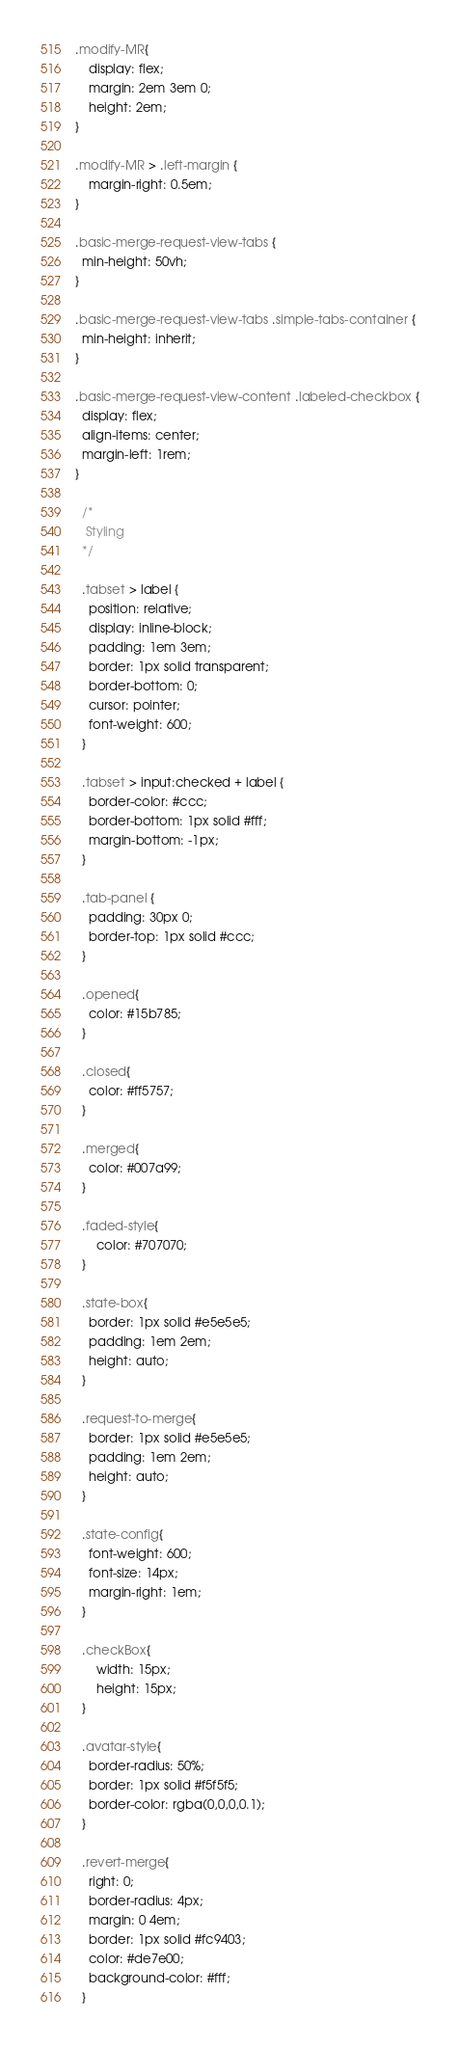Convert code to text. <code><loc_0><loc_0><loc_500><loc_500><_CSS_>.modify-MR{
    display: flex;
    margin: 2em 3em 0;
    height: 2em;
}

.modify-MR > .left-margin {
    margin-right: 0.5em;
}

.basic-merge-request-view-tabs {
  min-height: 50vh;
}

.basic-merge-request-view-tabs .simple-tabs-container {
  min-height: inherit;
}

.basic-merge-request-view-content .labeled-checkbox {
  display: flex;
  align-items: center;
  margin-left: 1rem;
}

  /*
   Styling
  */

  .tabset > label {
    position: relative;
    display: inline-block;
    padding: 1em 3em;
    border: 1px solid transparent;
    border-bottom: 0;
    cursor: pointer;
    font-weight: 600;
  }

  .tabset > input:checked + label {
    border-color: #ccc;
    border-bottom: 1px solid #fff;
    margin-bottom: -1px;
  }

  .tab-panel {
    padding: 30px 0;
    border-top: 1px solid #ccc;
  }

  .opened{
    color: #15b785;
  }

  .closed{
    color: #ff5757;
  }

  .merged{
    color: #007a99;
  }

  .faded-style{
      color: #707070;
  }

  .state-box{
    border: 1px solid #e5e5e5;
    padding: 1em 2em;
    height: auto;
  }

  .request-to-merge{
    border: 1px solid #e5e5e5;
    padding: 1em 2em;
    height: auto;
  }

  .state-config{
    font-weight: 600;
    font-size: 14px;
    margin-right: 1em;
  }

  .checkBox{
      width: 15px;
      height: 15px;
  }

  .avatar-style{
    border-radius: 50%;
    border: 1px solid #f5f5f5;
    border-color: rgba(0,0,0,0.1);
  }

  .revert-merge{
    right: 0;
    border-radius: 4px;
    margin: 0 4em;
    border: 1px solid #fc9403;
    color: #de7e00;
    background-color: #fff;
  }
</code> 